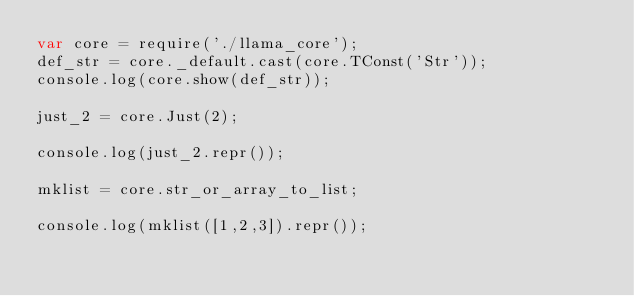<code> <loc_0><loc_0><loc_500><loc_500><_JavaScript_>var core = require('./llama_core');
def_str = core._default.cast(core.TConst('Str'));
console.log(core.show(def_str));

just_2 = core.Just(2);

console.log(just_2.repr());

mklist = core.str_or_array_to_list;

console.log(mklist([1,2,3]).repr());

</code> 